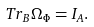<formula> <loc_0><loc_0><loc_500><loc_500>T r _ { B } \Omega _ { \Phi } = I _ { A } .</formula> 